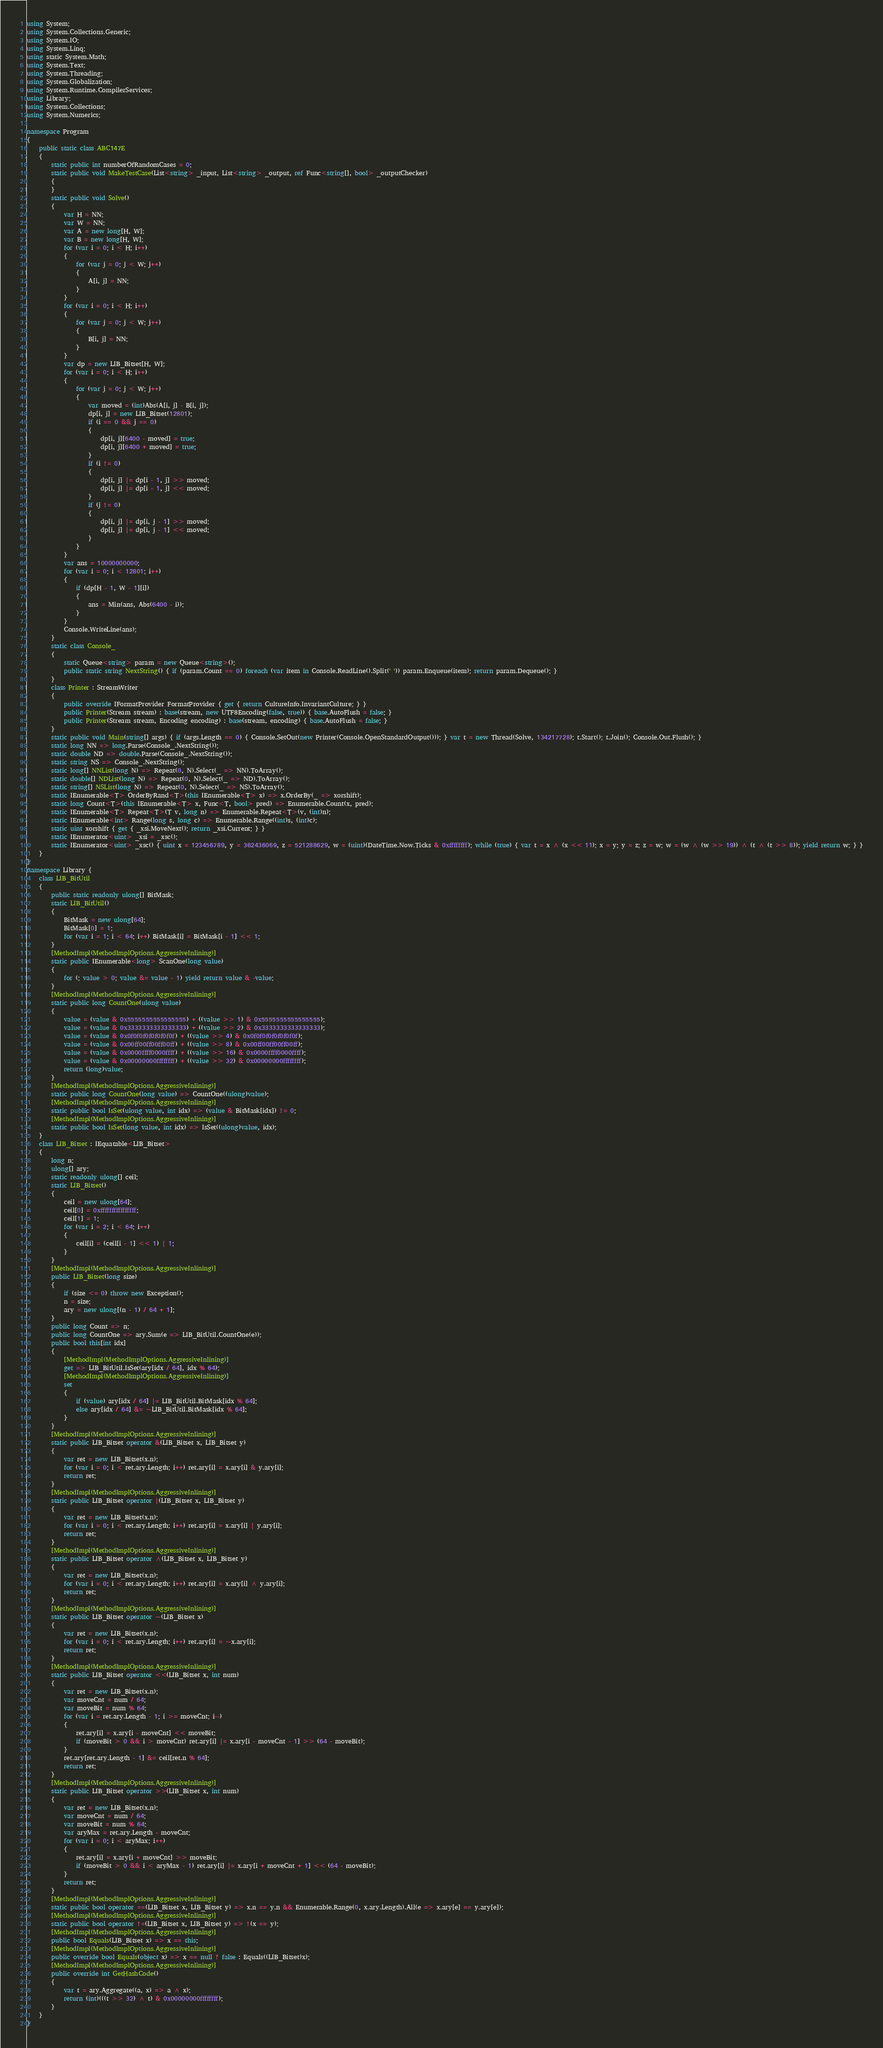<code> <loc_0><loc_0><loc_500><loc_500><_C#_>using System;
using System.Collections.Generic;
using System.IO;
using System.Linq;
using static System.Math;
using System.Text;
using System.Threading;
using System.Globalization;
using System.Runtime.CompilerServices;
using Library;
using System.Collections;
using System.Numerics;

namespace Program
{
    public static class ABC147E
    {
        static public int numberOfRandomCases = 0;
        static public void MakeTestCase(List<string> _input, List<string> _output, ref Func<string[], bool> _outputChecker)
        {
        }
        static public void Solve()
        {
            var H = NN;
            var W = NN;
            var A = new long[H, W];
            var B = new long[H, W];
            for (var i = 0; i < H; i++)
            {
                for (var j = 0; j < W; j++)
                {
                    A[i, j] = NN;
                }
            }
            for (var i = 0; i < H; i++)
            {
                for (var j = 0; j < W; j++)
                {
                    B[i, j] = NN;
                }
            }
            var dp = new LIB_Bitset[H, W];
            for (var i = 0; i < H; i++)
            {
                for (var j = 0; j < W; j++)
                {
                    var moved = (int)Abs(A[i, j] - B[i, j]);
                    dp[i, j] = new LIB_Bitset(12801);
                    if (i == 0 && j == 0)
                    {
                        dp[i, j][6400 - moved] = true;
                        dp[i, j][6400 + moved] = true;
                    }
                    if (i != 0)
                    {
                        dp[i, j] |= dp[i - 1, j] >> moved;
                        dp[i, j] |= dp[i - 1, j] << moved;
                    }
                    if (j != 0)
                    {
                        dp[i, j] |= dp[i, j - 1] >> moved;
                        dp[i, j] |= dp[i, j - 1] << moved;
                    }
                }
            }
            var ans = 10000000000;
            for (var i = 0; i < 12801; i++)
            {
                if (dp[H - 1, W - 1][i])
                {
                    ans = Min(ans, Abs(6400 - i));
                }
            }
            Console.WriteLine(ans);
        }
        static class Console_
        {
            static Queue<string> param = new Queue<string>();
            public static string NextString() { if (param.Count == 0) foreach (var item in Console.ReadLine().Split(' ')) param.Enqueue(item); return param.Dequeue(); }
        }
        class Printer : StreamWriter
        {
            public override IFormatProvider FormatProvider { get { return CultureInfo.InvariantCulture; } }
            public Printer(Stream stream) : base(stream, new UTF8Encoding(false, true)) { base.AutoFlush = false; }
            public Printer(Stream stream, Encoding encoding) : base(stream, encoding) { base.AutoFlush = false; }
        }
        static public void Main(string[] args) { if (args.Length == 0) { Console.SetOut(new Printer(Console.OpenStandardOutput())); } var t = new Thread(Solve, 134217728); t.Start(); t.Join(); Console.Out.Flush(); }
        static long NN => long.Parse(Console_.NextString());
        static double ND => double.Parse(Console_.NextString());
        static string NS => Console_.NextString();
        static long[] NNList(long N) => Repeat(0, N).Select(_ => NN).ToArray();
        static double[] NDList(long N) => Repeat(0, N).Select(_ => ND).ToArray();
        static string[] NSList(long N) => Repeat(0, N).Select(_ => NS).ToArray();
        static IEnumerable<T> OrderByRand<T>(this IEnumerable<T> x) => x.OrderBy(_ => xorshift);
        static long Count<T>(this IEnumerable<T> x, Func<T, bool> pred) => Enumerable.Count(x, pred);
        static IEnumerable<T> Repeat<T>(T v, long n) => Enumerable.Repeat<T>(v, (int)n);
        static IEnumerable<int> Range(long s, long c) => Enumerable.Range((int)s, (int)c);
        static uint xorshift { get { _xsi.MoveNext(); return _xsi.Current; } }
        static IEnumerator<uint> _xsi = _xsc();
        static IEnumerator<uint> _xsc() { uint x = 123456789, y = 362436069, z = 521288629, w = (uint)(DateTime.Now.Ticks & 0xffffffff); while (true) { var t = x ^ (x << 11); x = y; y = z; z = w; w = (w ^ (w >> 19)) ^ (t ^ (t >> 8)); yield return w; } }
    }
}
namespace Library {
    class LIB_BitUtil
    {
        public static readonly ulong[] BitMask;
        static LIB_BitUtil()
        {
            BitMask = new ulong[64];
            BitMask[0] = 1;
            for (var i = 1; i < 64; i++) BitMask[i] = BitMask[i - 1] << 1;
        }
        [MethodImpl(MethodImplOptions.AggressiveInlining)]
        static public IEnumerable<long> ScanOne(long value)
        {
            for (; value > 0; value &= value - 1) yield return value & -value;
        }
        [MethodImpl(MethodImplOptions.AggressiveInlining)]
        static public long CountOne(ulong value)
        {
            value = (value & 0x5555555555555555) + ((value >> 1) & 0x5555555555555555);
            value = (value & 0x3333333333333333) + ((value >> 2) & 0x3333333333333333);
            value = (value & 0x0f0f0f0f0f0f0f0f) + ((value >> 4) & 0x0f0f0f0f0f0f0f0f);
            value = (value & 0x00ff00ff00ff00ff) + ((value >> 8) & 0x00ff00ff00ff00ff);
            value = (value & 0x0000ffff0000ffff) + ((value >> 16) & 0x0000ffff0000ffff);
            value = (value & 0x00000000ffffffff) + ((value >> 32) & 0x00000000ffffffff);
            return (long)value;
        }
        [MethodImpl(MethodImplOptions.AggressiveInlining)]
        static public long CountOne(long value) => CountOne((ulong)value);
        [MethodImpl(MethodImplOptions.AggressiveInlining)]
        static public bool IsSet(ulong value, int idx) => (value & BitMask[idx]) != 0;
        [MethodImpl(MethodImplOptions.AggressiveInlining)]
        static public bool IsSet(long value, int idx) => IsSet((ulong)value, idx);
    }
    class LIB_Bitset : IEquatable<LIB_Bitset>
    {
        long n;
        ulong[] ary;
        static readonly ulong[] ceil;
        static LIB_Bitset()
        {
            ceil = new ulong[64];
            ceil[0] = 0xffffffffffffffff;
            ceil[1] = 1;
            for (var i = 2; i < 64; i++)
            {
                ceil[i] = (ceil[i - 1] << 1) | 1;
            }
        }
        [MethodImpl(MethodImplOptions.AggressiveInlining)]
        public LIB_Bitset(long size)
        {
            if (size <= 0) throw new Exception();
            n = size;
            ary = new ulong[(n - 1) / 64 + 1];
        }
        public long Count => n;
        public long CountOne => ary.Sum(e => LIB_BitUtil.CountOne(e));
        public bool this[int idx]
        {
            [MethodImpl(MethodImplOptions.AggressiveInlining)]
            get => LIB_BitUtil.IsSet(ary[idx / 64], idx % 64);
            [MethodImpl(MethodImplOptions.AggressiveInlining)]
            set
            {
                if (value) ary[idx / 64] |= LIB_BitUtil.BitMask[idx % 64];
                else ary[idx / 64] &= ~LIB_BitUtil.BitMask[idx % 64];
            }
        }
        [MethodImpl(MethodImplOptions.AggressiveInlining)]
        static public LIB_Bitset operator &(LIB_Bitset x, LIB_Bitset y)
        {
            var ret = new LIB_Bitset(x.n);
            for (var i = 0; i < ret.ary.Length; i++) ret.ary[i] = x.ary[i] & y.ary[i];
            return ret;
        }
        [MethodImpl(MethodImplOptions.AggressiveInlining)]
        static public LIB_Bitset operator |(LIB_Bitset x, LIB_Bitset y)
        {
            var ret = new LIB_Bitset(x.n);
            for (var i = 0; i < ret.ary.Length; i++) ret.ary[i] = x.ary[i] | y.ary[i];
            return ret;
        }
        [MethodImpl(MethodImplOptions.AggressiveInlining)]
        static public LIB_Bitset operator ^(LIB_Bitset x, LIB_Bitset y)
        {
            var ret = new LIB_Bitset(x.n);
            for (var i = 0; i < ret.ary.Length; i++) ret.ary[i] = x.ary[i] ^ y.ary[i];
            return ret;
        }
        [MethodImpl(MethodImplOptions.AggressiveInlining)]
        static public LIB_Bitset operator ~(LIB_Bitset x)
        {
            var ret = new LIB_Bitset(x.n);
            for (var i = 0; i < ret.ary.Length; i++) ret.ary[i] = ~x.ary[i];
            return ret;
        }
        [MethodImpl(MethodImplOptions.AggressiveInlining)]
        static public LIB_Bitset operator <<(LIB_Bitset x, int num)
        {
            var ret = new LIB_Bitset(x.n);
            var moveCnt = num / 64;
            var moveBit = num % 64;
            for (var i = ret.ary.Length - 1; i >= moveCnt; i--)
            {
                ret.ary[i] = x.ary[i - moveCnt] << moveBit;
                if (moveBit > 0 && i > moveCnt) ret.ary[i] |= x.ary[i - moveCnt - 1] >> (64 - moveBit);
            }
            ret.ary[ret.ary.Length - 1] &= ceil[ret.n % 64];
            return ret;
        }
        [MethodImpl(MethodImplOptions.AggressiveInlining)]
        static public LIB_Bitset operator >>(LIB_Bitset x, int num)
        {
            var ret = new LIB_Bitset(x.n);
            var moveCnt = num / 64;
            var moveBit = num % 64;
            var aryMax = ret.ary.Length - moveCnt;
            for (var i = 0; i < aryMax; i++)
            {
                ret.ary[i] = x.ary[i + moveCnt] >> moveBit;
                if (moveBit > 0 && i < aryMax - 1) ret.ary[i] |= x.ary[i + moveCnt + 1] << (64 - moveBit);
            }
            return ret;
        }
        [MethodImpl(MethodImplOptions.AggressiveInlining)]
        static public bool operator ==(LIB_Bitset x, LIB_Bitset y) => x.n == y.n && Enumerable.Range(0, x.ary.Length).All(e => x.ary[e] == y.ary[e]);
        [MethodImpl(MethodImplOptions.AggressiveInlining)]
        static public bool operator !=(LIB_Bitset x, LIB_Bitset y) => !(x == y);
        [MethodImpl(MethodImplOptions.AggressiveInlining)]
        public bool Equals(LIB_Bitset x) => x == this;
        [MethodImpl(MethodImplOptions.AggressiveInlining)]
        public override bool Equals(object x) => x == null ? false : Equals((LIB_Bitset)x);
        [MethodImpl(MethodImplOptions.AggressiveInlining)]
        public override int GetHashCode()
        {
            var t = ary.Aggregate((a, x) => a ^ x);
            return (int)(((t >> 32) ^ t) & 0x00000000ffffffff);
        }
    }
}
</code> 